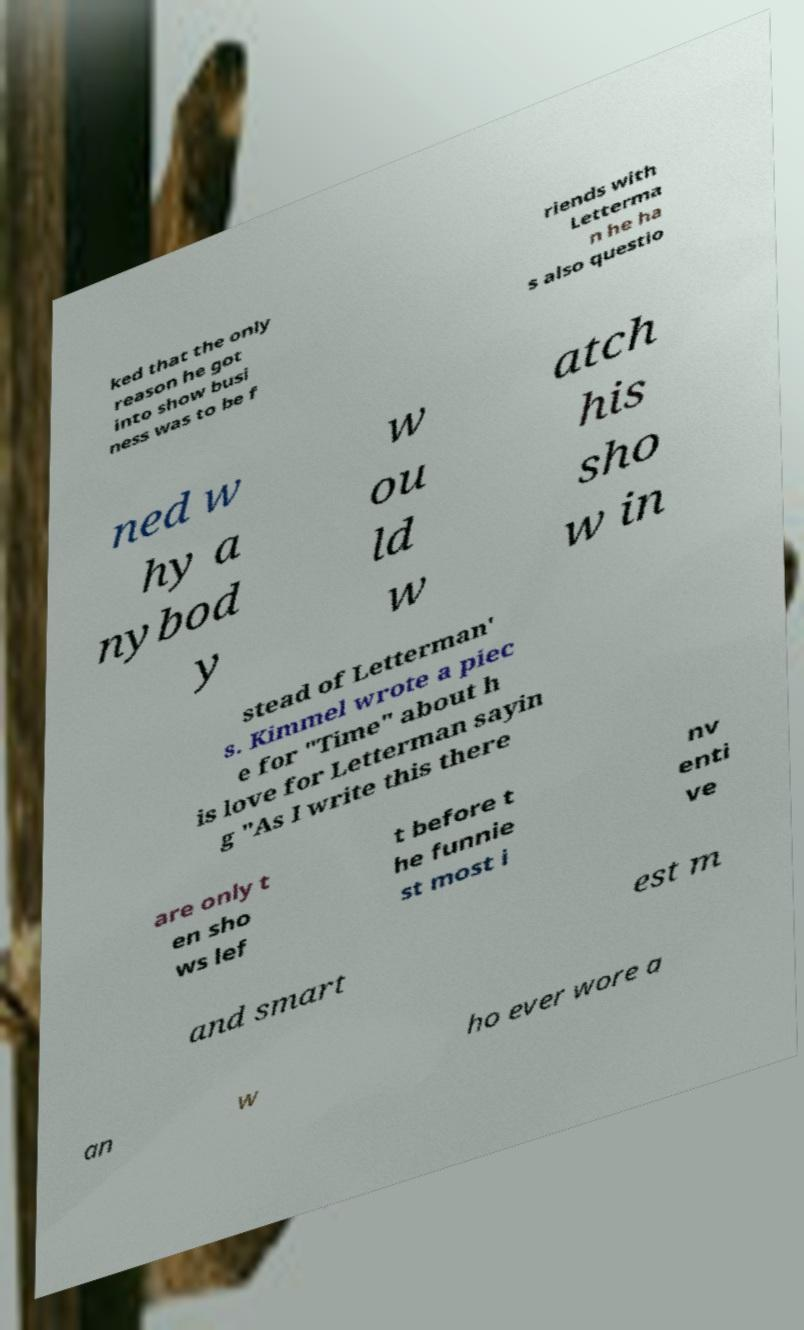Please identify and transcribe the text found in this image. ked that the only reason he got into show busi ness was to be f riends with Letterma n he ha s also questio ned w hy a nybod y w ou ld w atch his sho w in stead of Letterman' s. Kimmel wrote a piec e for "Time" about h is love for Letterman sayin g "As I write this there are only t en sho ws lef t before t he funnie st most i nv enti ve and smart est m an w ho ever wore a 